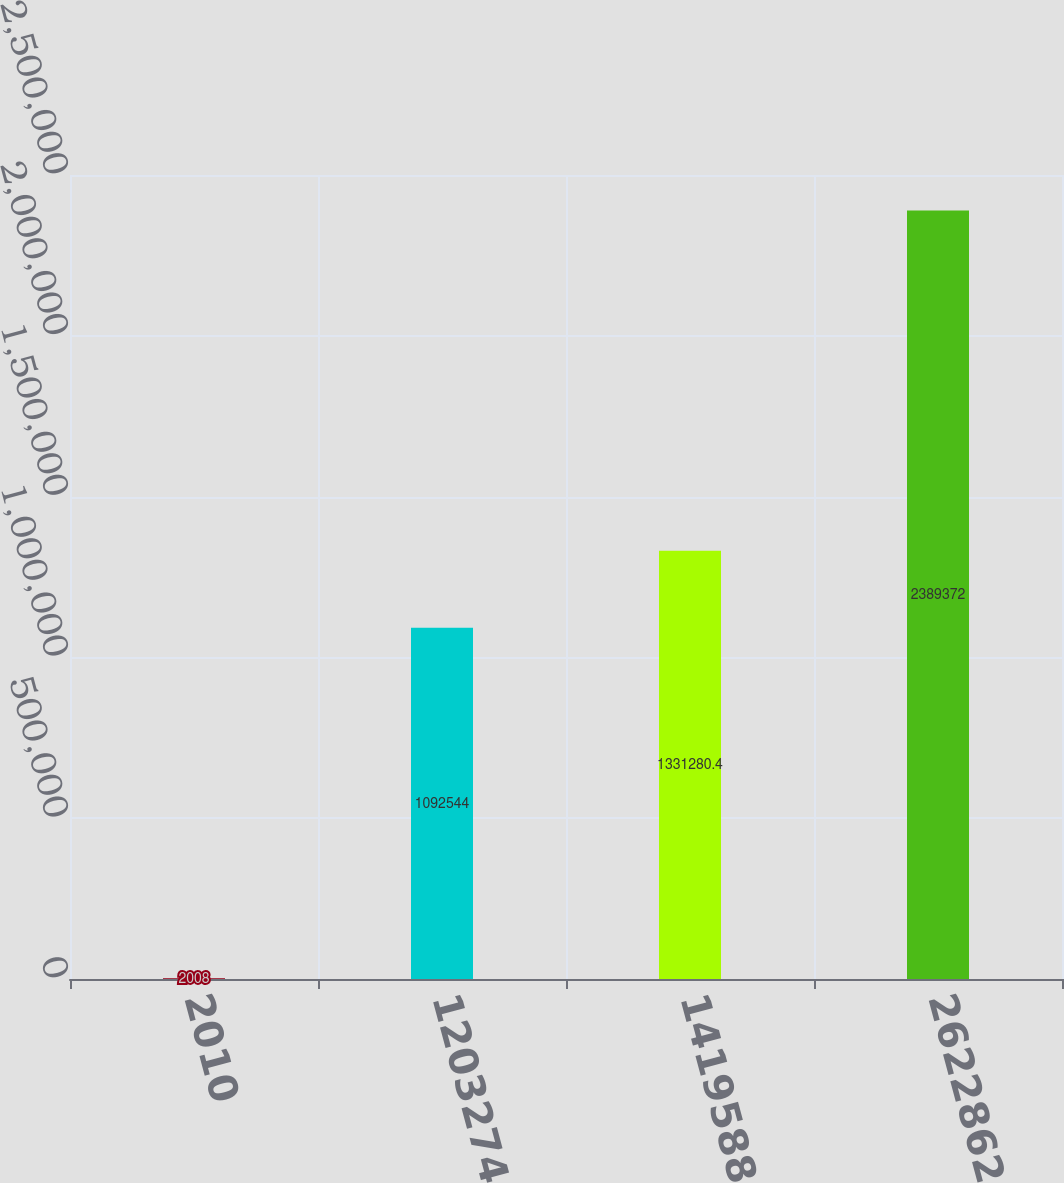Convert chart to OTSL. <chart><loc_0><loc_0><loc_500><loc_500><bar_chart><fcel>2010<fcel>1203274<fcel>1419588<fcel>2622862<nl><fcel>2008<fcel>1.09254e+06<fcel>1.33128e+06<fcel>2.38937e+06<nl></chart> 